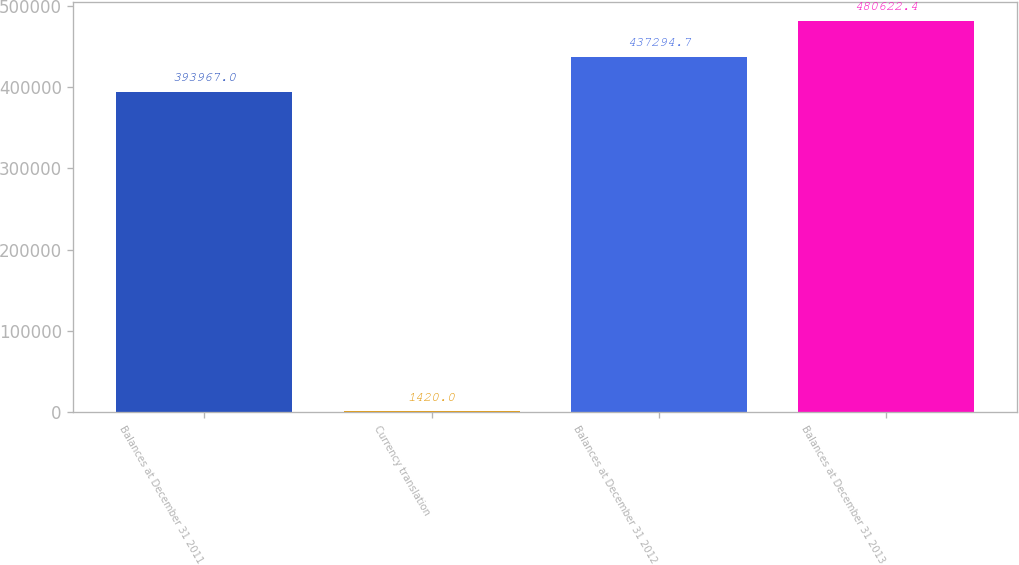<chart> <loc_0><loc_0><loc_500><loc_500><bar_chart><fcel>Balances at December 31 2011<fcel>Currency translation<fcel>Balances at December 31 2012<fcel>Balances at December 31 2013<nl><fcel>393967<fcel>1420<fcel>437295<fcel>480622<nl></chart> 